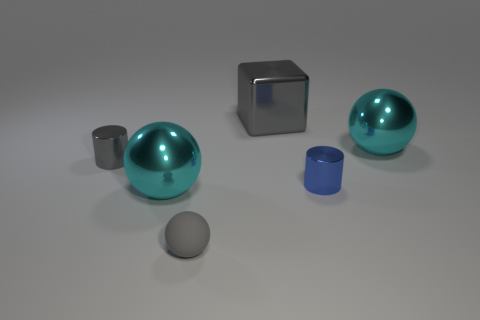Add 3 purple shiny cylinders. How many objects exist? 9 Subtract all cubes. How many objects are left? 5 Subtract all gray balls. Subtract all large cubes. How many objects are left? 4 Add 6 cyan metal objects. How many cyan metal objects are left? 8 Add 1 purple rubber things. How many purple rubber things exist? 1 Subtract 0 red cubes. How many objects are left? 6 